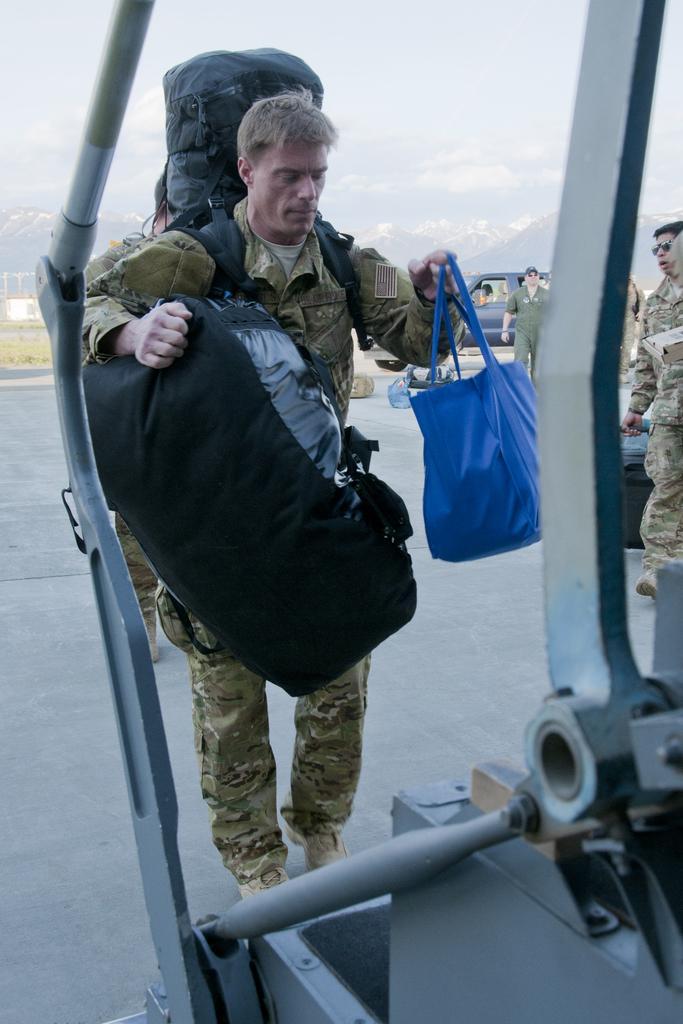How would you summarize this image in a sentence or two? In this image, in the middle there is a man, he is holding bags. At the bottom there is staircase. In the background there are people, vehicle, hills, grass, road, sky. 